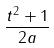<formula> <loc_0><loc_0><loc_500><loc_500>\frac { t ^ { 2 } + 1 } { 2 a }</formula> 